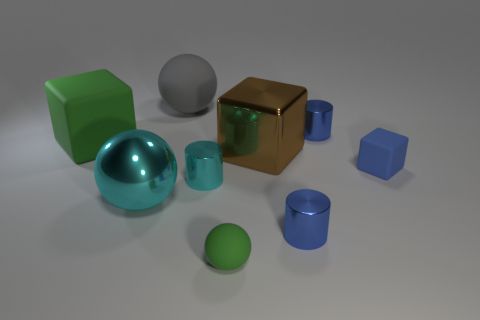Subtract all small blue shiny cylinders. How many cylinders are left? 1 Subtract all balls. How many objects are left? 6 Subtract all gray balls. How many balls are left? 2 Subtract all purple spheres. How many purple cylinders are left? 0 Subtract 0 blue balls. How many objects are left? 9 Subtract 3 balls. How many balls are left? 0 Subtract all brown cylinders. Subtract all red balls. How many cylinders are left? 3 Subtract all blue matte cubes. Subtract all big metallic spheres. How many objects are left? 7 Add 7 cyan metallic things. How many cyan metallic things are left? 9 Add 1 large shiny balls. How many large shiny balls exist? 2 